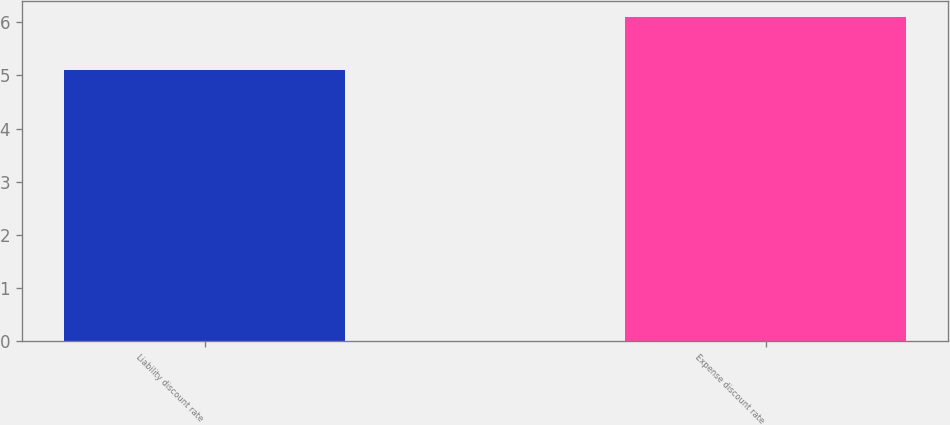Convert chart to OTSL. <chart><loc_0><loc_0><loc_500><loc_500><bar_chart><fcel>Liability discount rate<fcel>Expense discount rate<nl><fcel>5.1<fcel>6.1<nl></chart> 